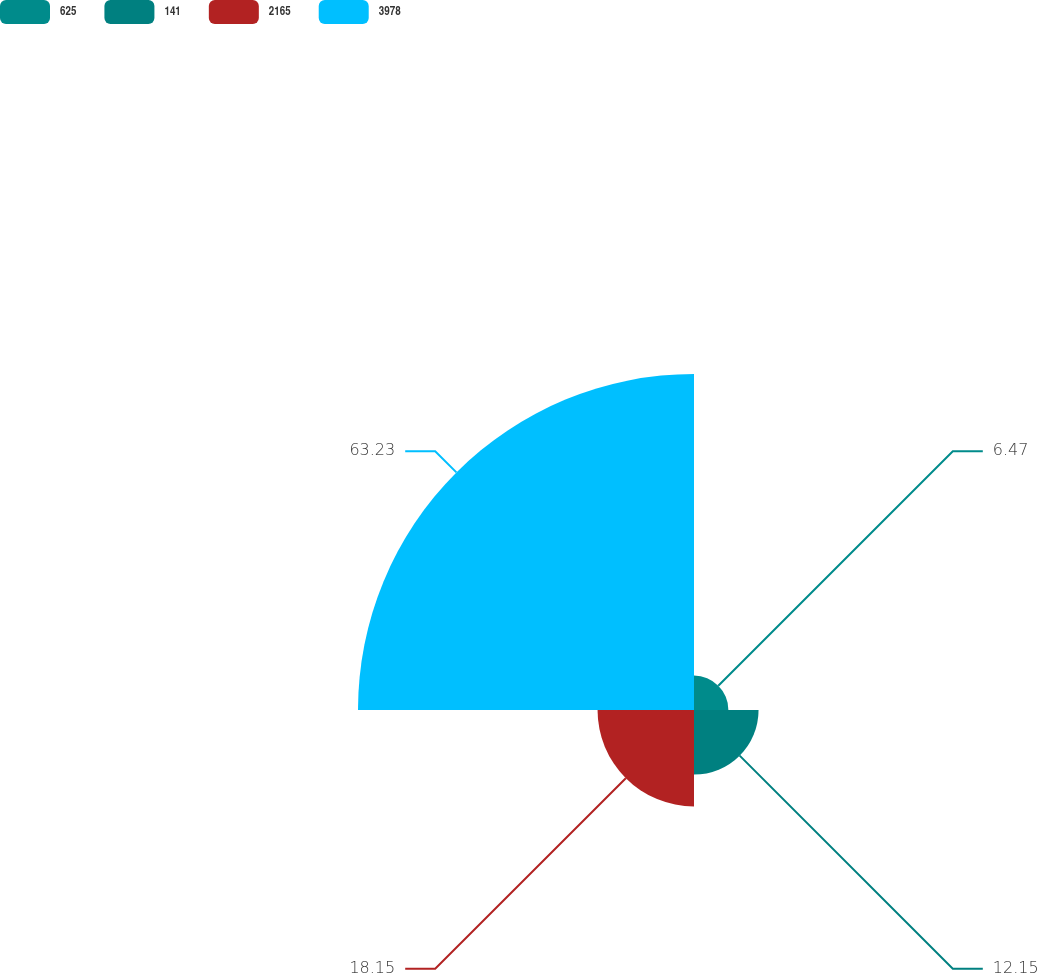<chart> <loc_0><loc_0><loc_500><loc_500><pie_chart><fcel>625<fcel>141<fcel>2165<fcel>3978<nl><fcel>6.47%<fcel>12.15%<fcel>18.15%<fcel>63.23%<nl></chart> 